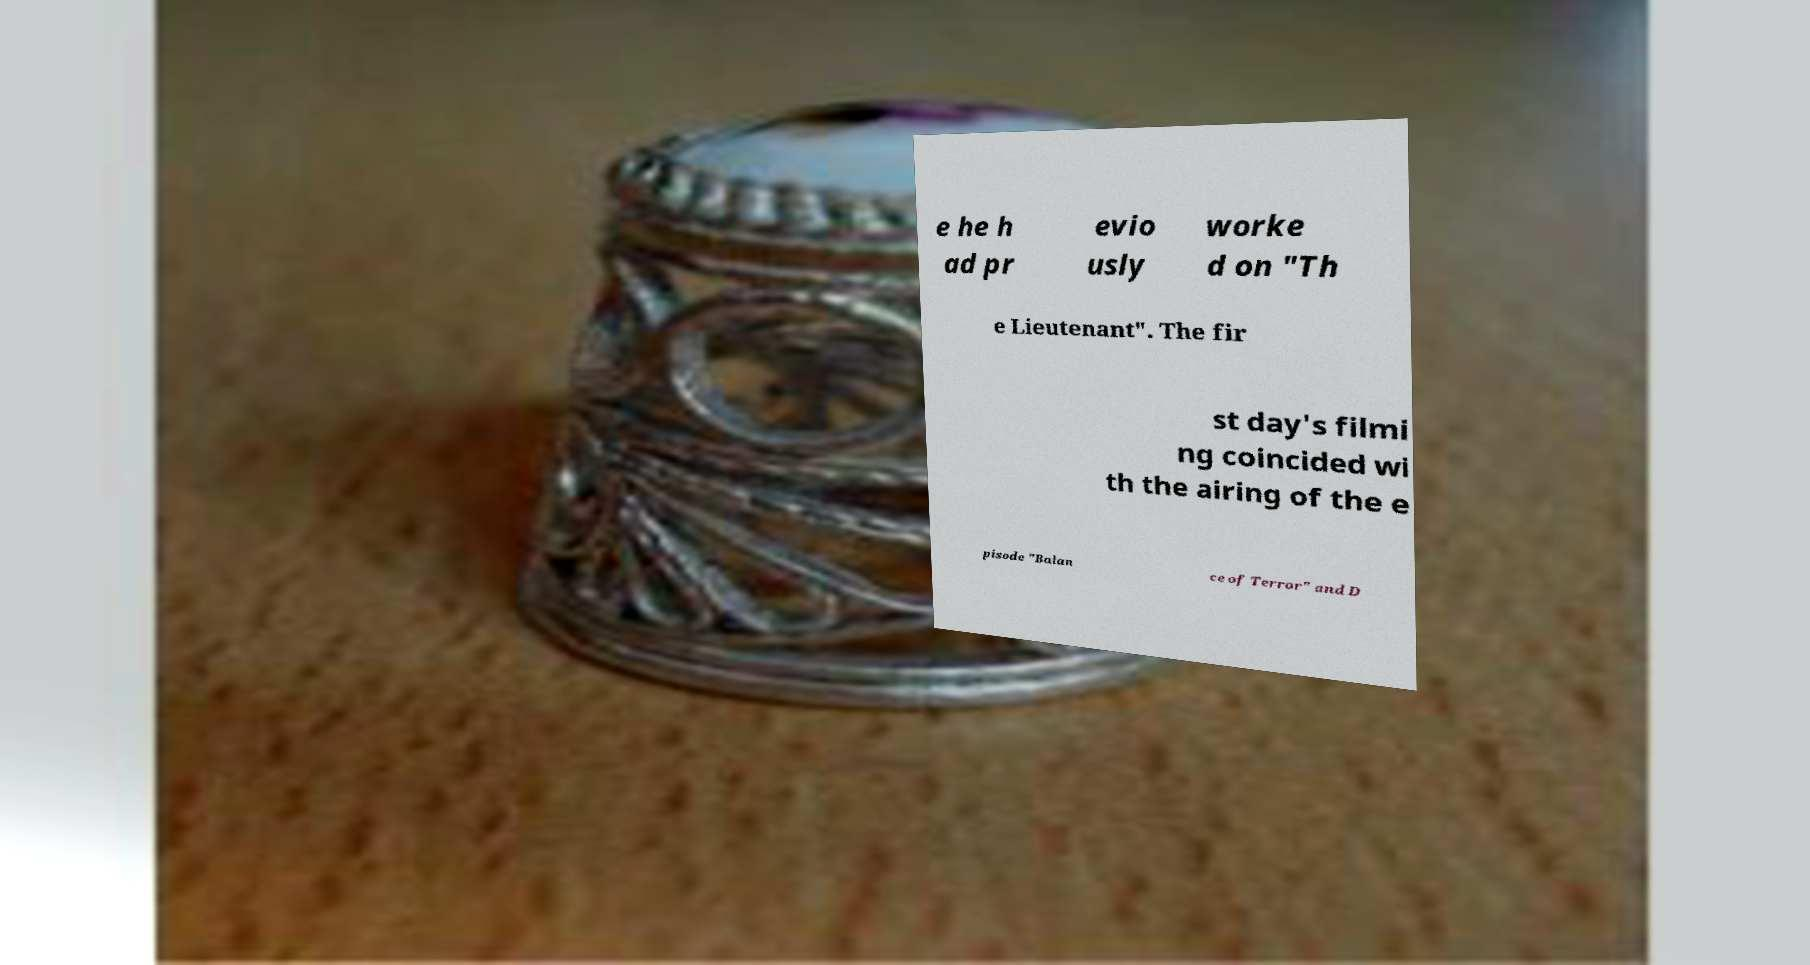What messages or text are displayed in this image? I need them in a readable, typed format. e he h ad pr evio usly worke d on "Th e Lieutenant". The fir st day's filmi ng coincided wi th the airing of the e pisode "Balan ce of Terror" and D 